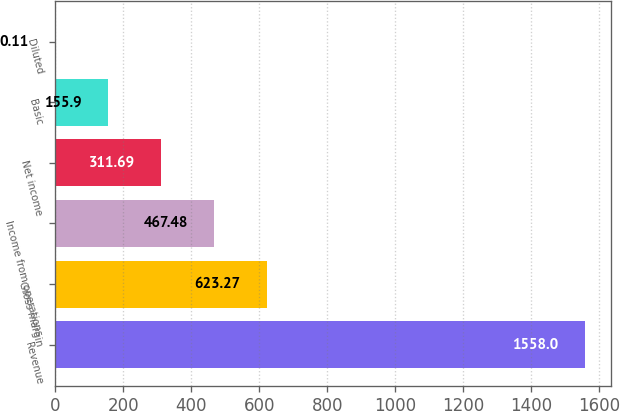<chart> <loc_0><loc_0><loc_500><loc_500><bar_chart><fcel>Revenue<fcel>Gross margin<fcel>Income from operations<fcel>Net income<fcel>Basic<fcel>Diluted<nl><fcel>1558<fcel>623.27<fcel>467.48<fcel>311.69<fcel>155.9<fcel>0.11<nl></chart> 